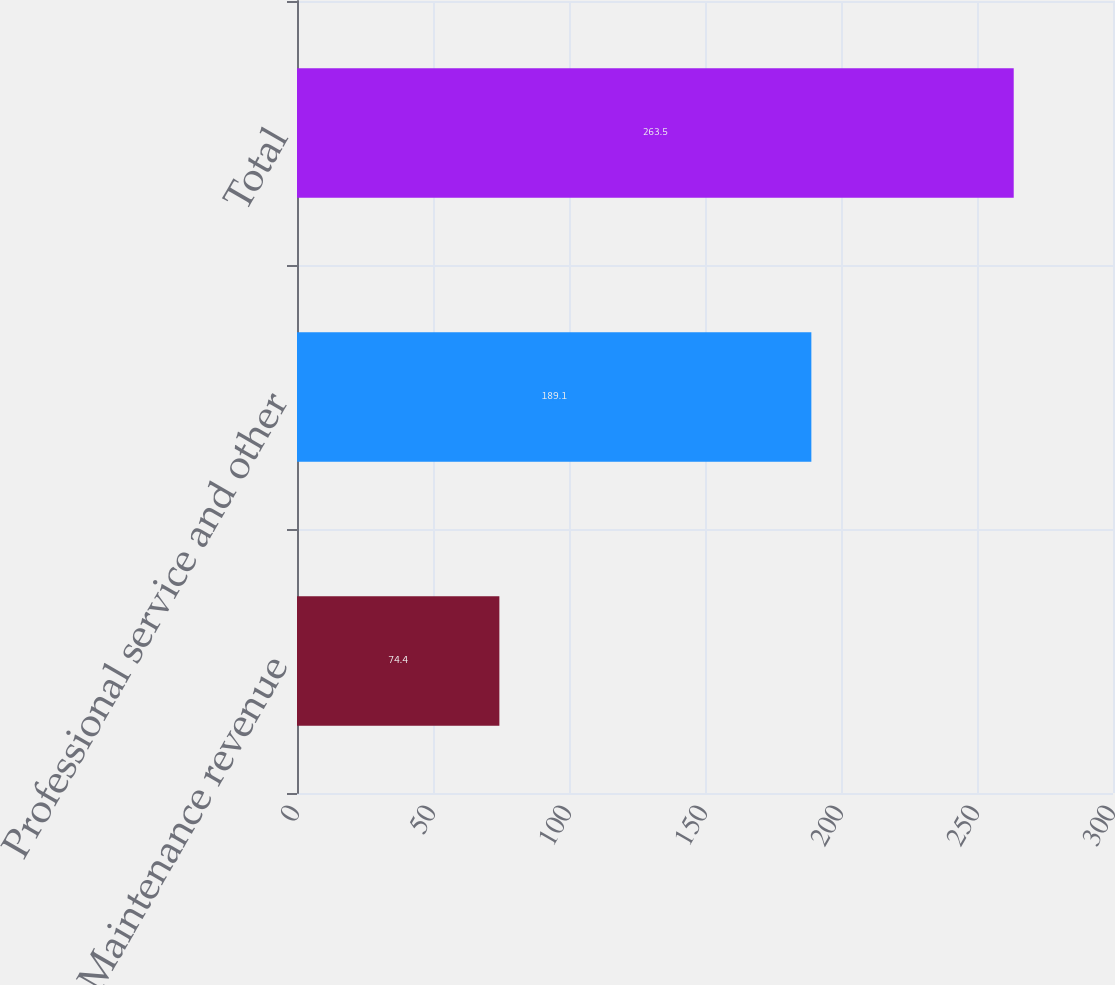Convert chart to OTSL. <chart><loc_0><loc_0><loc_500><loc_500><bar_chart><fcel>Maintenance revenue<fcel>Professional service and other<fcel>Total<nl><fcel>74.4<fcel>189.1<fcel>263.5<nl></chart> 